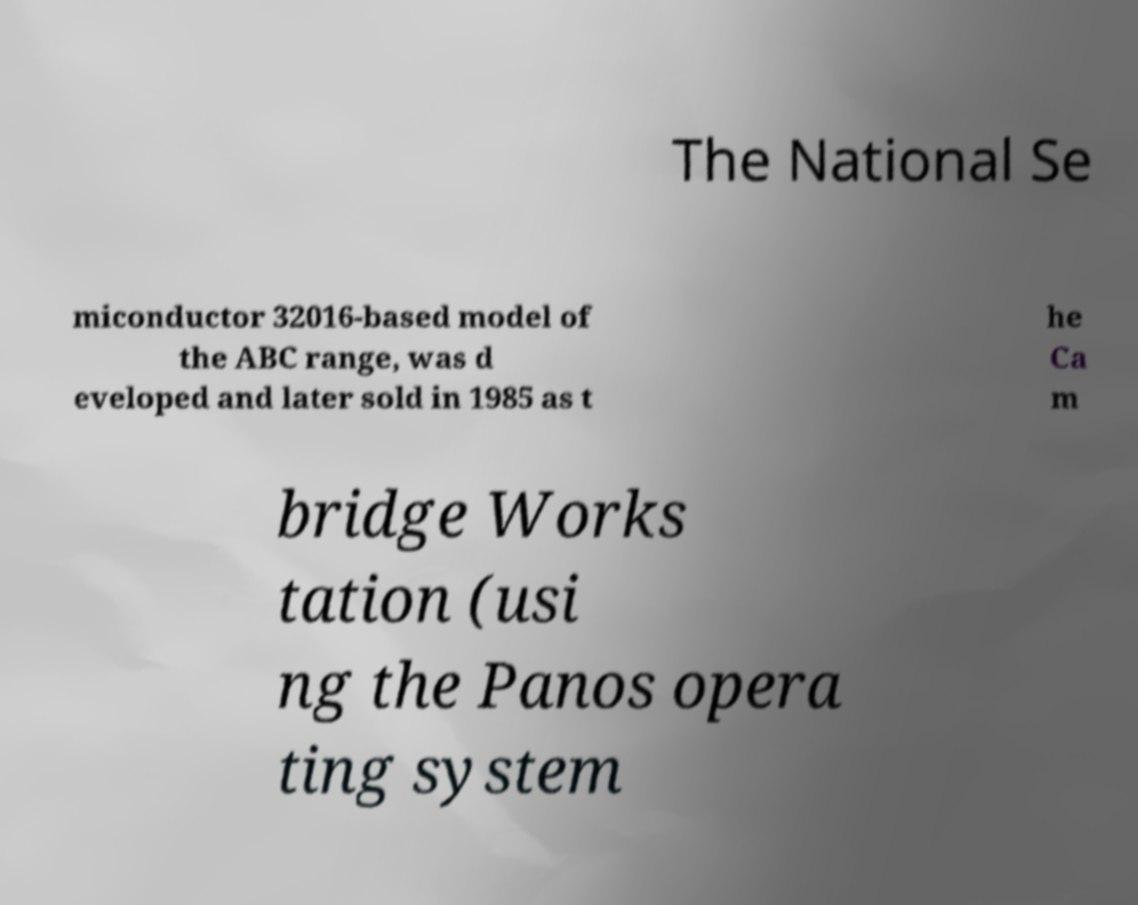I need the written content from this picture converted into text. Can you do that? The National Se miconductor 32016-based model of the ABC range, was d eveloped and later sold in 1985 as t he Ca m bridge Works tation (usi ng the Panos opera ting system 